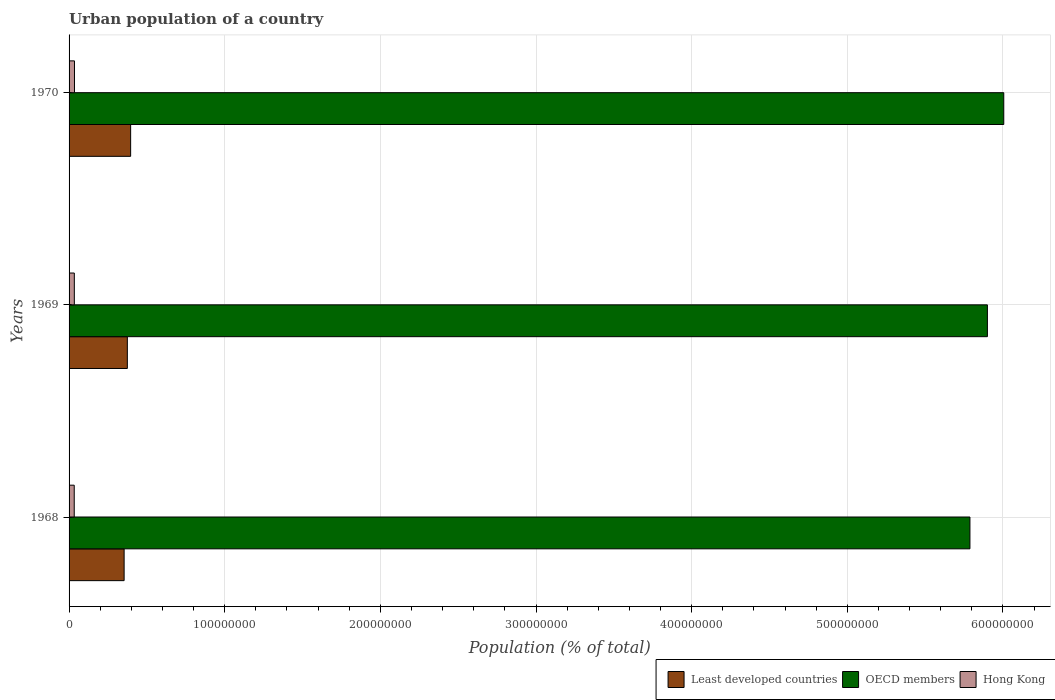How many groups of bars are there?
Offer a terse response. 3. Are the number of bars per tick equal to the number of legend labels?
Your answer should be very brief. Yes. Are the number of bars on each tick of the Y-axis equal?
Your response must be concise. Yes. What is the label of the 3rd group of bars from the top?
Offer a terse response. 1968. In how many cases, is the number of bars for a given year not equal to the number of legend labels?
Offer a terse response. 0. What is the urban population in Least developed countries in 1968?
Your answer should be very brief. 3.54e+07. Across all years, what is the maximum urban population in OECD members?
Your response must be concise. 6.01e+08. Across all years, what is the minimum urban population in OECD members?
Offer a very short reply. 5.79e+08. In which year was the urban population in Hong Kong minimum?
Offer a very short reply. 1968. What is the total urban population in OECD members in the graph?
Your answer should be compact. 1.77e+09. What is the difference between the urban population in Hong Kong in 1969 and that in 1970?
Make the answer very short. -9.32e+04. What is the difference between the urban population in Hong Kong in 1970 and the urban population in OECD members in 1968?
Offer a very short reply. -5.75e+08. What is the average urban population in Least developed countries per year?
Offer a very short reply. 3.75e+07. In the year 1968, what is the difference between the urban population in Least developed countries and urban population in Hong Kong?
Provide a succinct answer. 3.21e+07. What is the ratio of the urban population in Least developed countries in 1968 to that in 1969?
Your answer should be very brief. 0.94. What is the difference between the highest and the second highest urban population in OECD members?
Your answer should be compact. 1.05e+07. What is the difference between the highest and the lowest urban population in Hong Kong?
Offer a very short reply. 1.56e+05. Is the sum of the urban population in Least developed countries in 1969 and 1970 greater than the maximum urban population in OECD members across all years?
Give a very brief answer. No. What does the 3rd bar from the top in 1969 represents?
Give a very brief answer. Least developed countries. What does the 3rd bar from the bottom in 1969 represents?
Provide a succinct answer. Hong Kong. Are all the bars in the graph horizontal?
Keep it short and to the point. Yes. What is the difference between two consecutive major ticks on the X-axis?
Provide a short and direct response. 1.00e+08. Are the values on the major ticks of X-axis written in scientific E-notation?
Give a very brief answer. No. Does the graph contain any zero values?
Give a very brief answer. No. Does the graph contain grids?
Give a very brief answer. Yes. Where does the legend appear in the graph?
Offer a very short reply. Bottom right. How many legend labels are there?
Offer a very short reply. 3. How are the legend labels stacked?
Your response must be concise. Horizontal. What is the title of the graph?
Offer a terse response. Urban population of a country. What is the label or title of the X-axis?
Your answer should be compact. Population (% of total). What is the label or title of the Y-axis?
Ensure brevity in your answer.  Years. What is the Population (% of total) of Least developed countries in 1968?
Your answer should be compact. 3.54e+07. What is the Population (% of total) in OECD members in 1968?
Ensure brevity in your answer.  5.79e+08. What is the Population (% of total) of Hong Kong in 1968?
Keep it short and to the point. 3.32e+06. What is the Population (% of total) in Least developed countries in 1969?
Provide a succinct answer. 3.74e+07. What is the Population (% of total) of OECD members in 1969?
Make the answer very short. 5.90e+08. What is the Population (% of total) of Hong Kong in 1969?
Your answer should be compact. 3.38e+06. What is the Population (% of total) of Least developed countries in 1970?
Ensure brevity in your answer.  3.96e+07. What is the Population (% of total) of OECD members in 1970?
Make the answer very short. 6.01e+08. What is the Population (% of total) in Hong Kong in 1970?
Provide a succinct answer. 3.47e+06. Across all years, what is the maximum Population (% of total) of Least developed countries?
Offer a terse response. 3.96e+07. Across all years, what is the maximum Population (% of total) in OECD members?
Make the answer very short. 6.01e+08. Across all years, what is the maximum Population (% of total) of Hong Kong?
Ensure brevity in your answer.  3.47e+06. Across all years, what is the minimum Population (% of total) in Least developed countries?
Provide a succinct answer. 3.54e+07. Across all years, what is the minimum Population (% of total) in OECD members?
Ensure brevity in your answer.  5.79e+08. Across all years, what is the minimum Population (% of total) of Hong Kong?
Your answer should be very brief. 3.32e+06. What is the total Population (% of total) in Least developed countries in the graph?
Your answer should be very brief. 1.12e+08. What is the total Population (% of total) of OECD members in the graph?
Keep it short and to the point. 1.77e+09. What is the total Population (% of total) in Hong Kong in the graph?
Give a very brief answer. 1.02e+07. What is the difference between the Population (% of total) in Least developed countries in 1968 and that in 1969?
Make the answer very short. -2.07e+06. What is the difference between the Population (% of total) of OECD members in 1968 and that in 1969?
Your response must be concise. -1.12e+07. What is the difference between the Population (% of total) of Hong Kong in 1968 and that in 1969?
Provide a short and direct response. -6.33e+04. What is the difference between the Population (% of total) in Least developed countries in 1968 and that in 1970?
Keep it short and to the point. -4.19e+06. What is the difference between the Population (% of total) of OECD members in 1968 and that in 1970?
Offer a terse response. -2.17e+07. What is the difference between the Population (% of total) of Hong Kong in 1968 and that in 1970?
Your answer should be very brief. -1.56e+05. What is the difference between the Population (% of total) in Least developed countries in 1969 and that in 1970?
Ensure brevity in your answer.  -2.12e+06. What is the difference between the Population (% of total) of OECD members in 1969 and that in 1970?
Ensure brevity in your answer.  -1.05e+07. What is the difference between the Population (% of total) in Hong Kong in 1969 and that in 1970?
Offer a terse response. -9.32e+04. What is the difference between the Population (% of total) of Least developed countries in 1968 and the Population (% of total) of OECD members in 1969?
Make the answer very short. -5.55e+08. What is the difference between the Population (% of total) of Least developed countries in 1968 and the Population (% of total) of Hong Kong in 1969?
Provide a short and direct response. 3.20e+07. What is the difference between the Population (% of total) in OECD members in 1968 and the Population (% of total) in Hong Kong in 1969?
Give a very brief answer. 5.75e+08. What is the difference between the Population (% of total) of Least developed countries in 1968 and the Population (% of total) of OECD members in 1970?
Give a very brief answer. -5.65e+08. What is the difference between the Population (% of total) of Least developed countries in 1968 and the Population (% of total) of Hong Kong in 1970?
Your answer should be compact. 3.19e+07. What is the difference between the Population (% of total) in OECD members in 1968 and the Population (% of total) in Hong Kong in 1970?
Ensure brevity in your answer.  5.75e+08. What is the difference between the Population (% of total) in Least developed countries in 1969 and the Population (% of total) in OECD members in 1970?
Your answer should be very brief. -5.63e+08. What is the difference between the Population (% of total) in Least developed countries in 1969 and the Population (% of total) in Hong Kong in 1970?
Ensure brevity in your answer.  3.40e+07. What is the difference between the Population (% of total) in OECD members in 1969 and the Population (% of total) in Hong Kong in 1970?
Ensure brevity in your answer.  5.87e+08. What is the average Population (% of total) of Least developed countries per year?
Keep it short and to the point. 3.75e+07. What is the average Population (% of total) in OECD members per year?
Provide a succinct answer. 5.90e+08. What is the average Population (% of total) of Hong Kong per year?
Ensure brevity in your answer.  3.39e+06. In the year 1968, what is the difference between the Population (% of total) of Least developed countries and Population (% of total) of OECD members?
Your answer should be very brief. -5.43e+08. In the year 1968, what is the difference between the Population (% of total) of Least developed countries and Population (% of total) of Hong Kong?
Provide a succinct answer. 3.21e+07. In the year 1968, what is the difference between the Population (% of total) of OECD members and Population (% of total) of Hong Kong?
Make the answer very short. 5.75e+08. In the year 1969, what is the difference between the Population (% of total) in Least developed countries and Population (% of total) in OECD members?
Keep it short and to the point. -5.53e+08. In the year 1969, what is the difference between the Population (% of total) in Least developed countries and Population (% of total) in Hong Kong?
Offer a very short reply. 3.41e+07. In the year 1969, what is the difference between the Population (% of total) in OECD members and Population (% of total) in Hong Kong?
Offer a very short reply. 5.87e+08. In the year 1970, what is the difference between the Population (% of total) in Least developed countries and Population (% of total) in OECD members?
Provide a short and direct response. -5.61e+08. In the year 1970, what is the difference between the Population (% of total) in Least developed countries and Population (% of total) in Hong Kong?
Offer a very short reply. 3.61e+07. In the year 1970, what is the difference between the Population (% of total) in OECD members and Population (% of total) in Hong Kong?
Offer a very short reply. 5.97e+08. What is the ratio of the Population (% of total) of Least developed countries in 1968 to that in 1969?
Offer a terse response. 0.94. What is the ratio of the Population (% of total) of Hong Kong in 1968 to that in 1969?
Your answer should be very brief. 0.98. What is the ratio of the Population (% of total) in Least developed countries in 1968 to that in 1970?
Offer a very short reply. 0.89. What is the ratio of the Population (% of total) in OECD members in 1968 to that in 1970?
Give a very brief answer. 0.96. What is the ratio of the Population (% of total) of Hong Kong in 1968 to that in 1970?
Provide a short and direct response. 0.95. What is the ratio of the Population (% of total) of Least developed countries in 1969 to that in 1970?
Your response must be concise. 0.95. What is the ratio of the Population (% of total) of OECD members in 1969 to that in 1970?
Your answer should be very brief. 0.98. What is the ratio of the Population (% of total) in Hong Kong in 1969 to that in 1970?
Provide a short and direct response. 0.97. What is the difference between the highest and the second highest Population (% of total) of Least developed countries?
Provide a short and direct response. 2.12e+06. What is the difference between the highest and the second highest Population (% of total) in OECD members?
Ensure brevity in your answer.  1.05e+07. What is the difference between the highest and the second highest Population (% of total) of Hong Kong?
Ensure brevity in your answer.  9.32e+04. What is the difference between the highest and the lowest Population (% of total) of Least developed countries?
Give a very brief answer. 4.19e+06. What is the difference between the highest and the lowest Population (% of total) in OECD members?
Offer a terse response. 2.17e+07. What is the difference between the highest and the lowest Population (% of total) of Hong Kong?
Provide a succinct answer. 1.56e+05. 